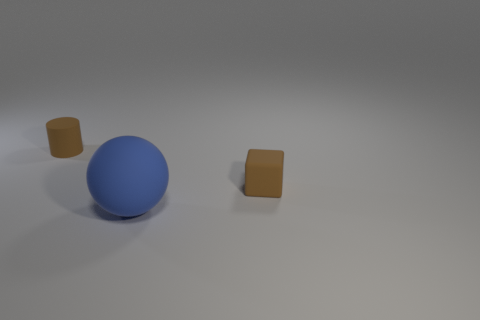Add 3 red shiny spheres. How many objects exist? 6 Subtract all spheres. How many objects are left? 2 Subtract all gray rubber things. Subtract all big things. How many objects are left? 2 Add 1 brown matte cylinders. How many brown matte cylinders are left? 2 Add 3 brown metallic cylinders. How many brown metallic cylinders exist? 3 Subtract 0 purple blocks. How many objects are left? 3 